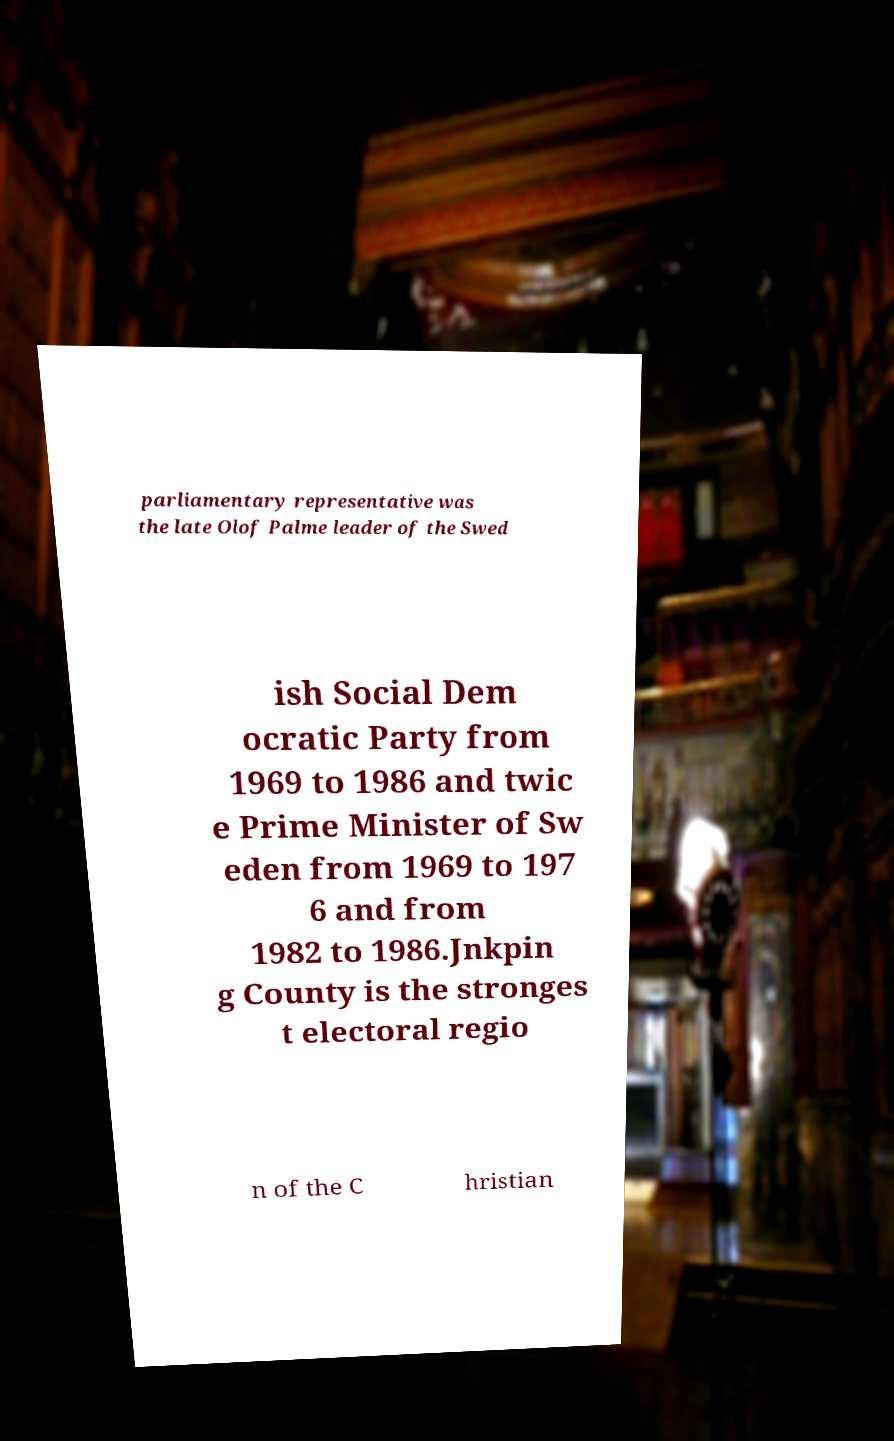There's text embedded in this image that I need extracted. Can you transcribe it verbatim? parliamentary representative was the late Olof Palme leader of the Swed ish Social Dem ocratic Party from 1969 to 1986 and twic e Prime Minister of Sw eden from 1969 to 197 6 and from 1982 to 1986.Jnkpin g County is the stronges t electoral regio n of the C hristian 